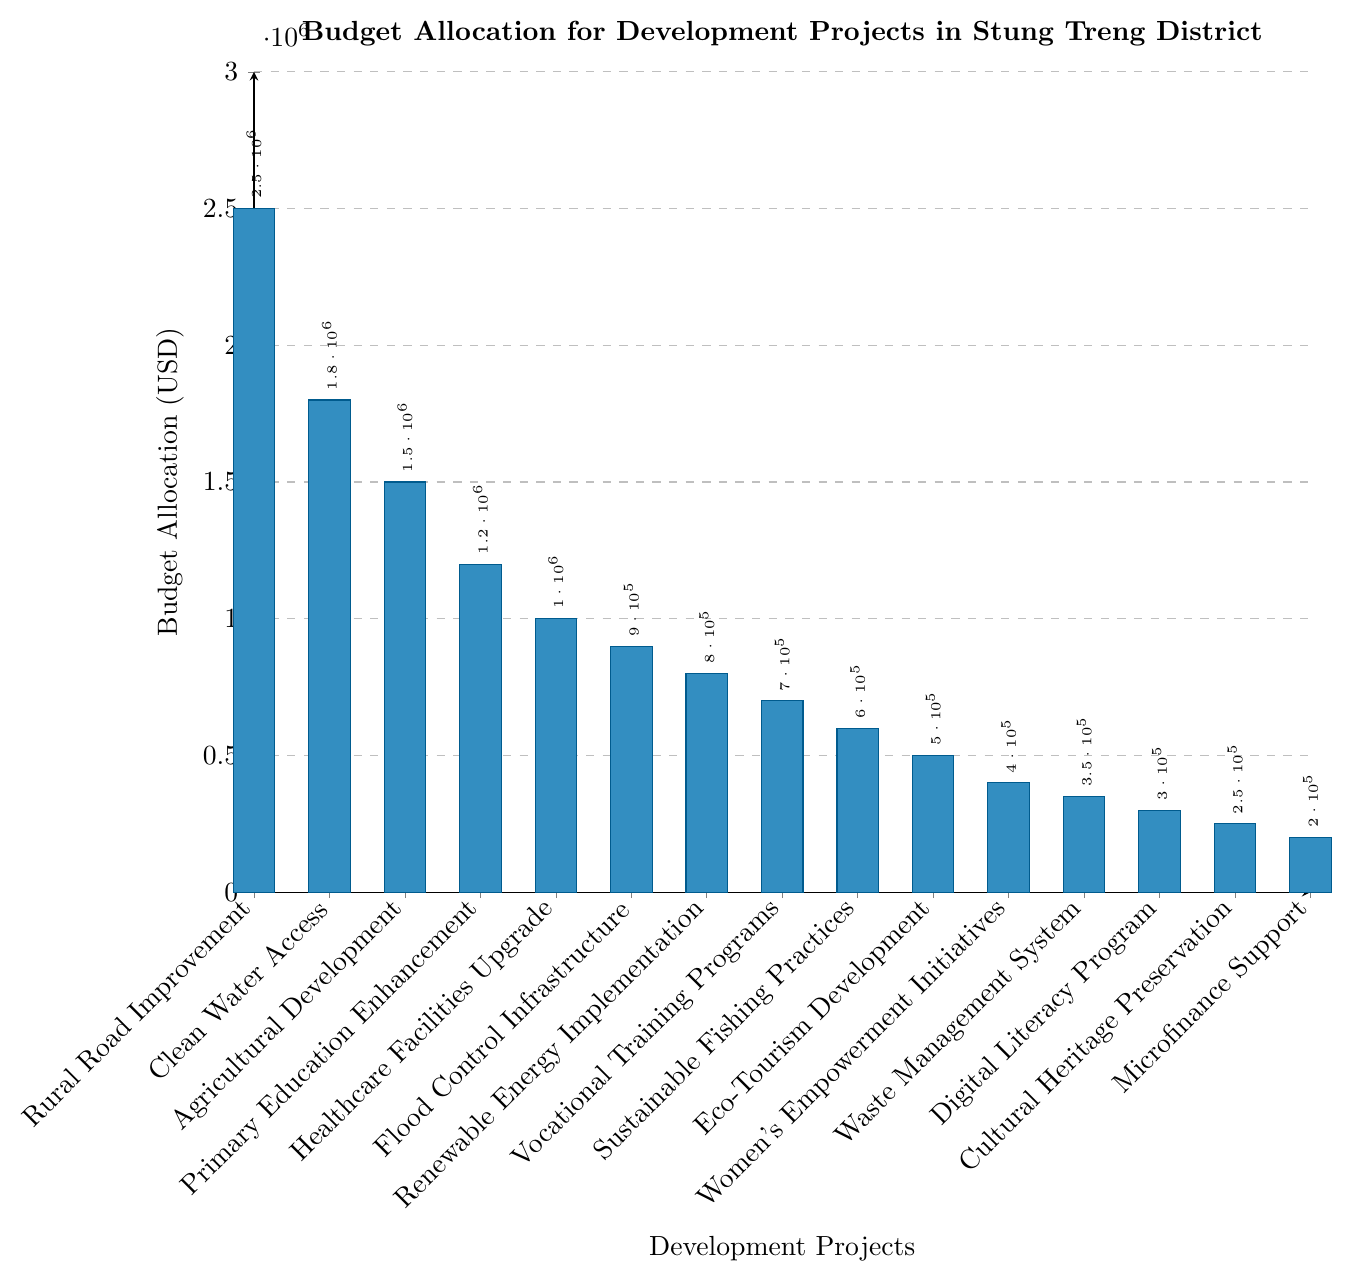Which project has the highest budget allocation? The figure shows a bar chart with each bar representing a project's budget allocation. The bar for "Rural Road Improvement" is the tallest, indicating it has the highest budget allocation.
Answer: Rural Road Improvement Which project has the lowest budget allocation? The chart indicates that the bar for "Microfinance Support" is the shortest among all bars, making it the project with the lowest budget allocation.
Answer: Microfinance Support How much more budget is allocated to Clean Water Access compared to Renewable Energy Implementation? Find the heights of the bars for "Clean Water Access" and "Renewable Energy Implementation". The difference is $1,800,000 - $800,000 = $1,000,000.
Answer: $1,000,000 **Compositional Questions:**
   
What is the total budget allocated to the projects focused on environmental sustainability (Flood Control Infrastructure, Renewable Energy Implementation, Sustainable Fishing Practices)? Sum the budgets for "Flood Control Infrastructure" ($900,000), "Renewable Energy Implementation" ($800,000), and "Sustainable Fishing Practices" ($600,000). The total is $900,000 + $800,000 + $600,000 = $2,300,000.
Answer: $2,300,000 What is the average budget allocation for the top 3 projects? Identify the top three projects: "Rural Road Improvement", "Clean Water Access", and "Agricultural Development" with budgets $2,500,000, $1,800,000, and $1,500,000 respectively. The average is calculated as ($2,500,000 + $1,800,000 + $1,500,000) / 3 = $5,800,000 / 3 ≈ $1,933,333.33
Answer: $1,933,333.33 What is the total budget allocated to Healthcare Facilities Upgrade and Primary Education Enhancement? Add the budget allocations for "Healthcare Facilities Upgrade" ($1,000,000) and "Primary Education Enhancement" ($1,200,000). $1,000,000 + $1,200,000 = $2,200,000
Answer: $2,200,000 Which bar is the second tallest? Observe the heights of all bars in the chart. The second tallest bar corresponds to the "Clean Water Access" project.
Answer: Clean Water Access How many projects have a budget allocation greater than $1,000,000? Count the number of bars that surpass the $1,000,000 mark. The bars for "Rural Road Improvement", "Clean Water Access", "Agricultural Development", and "Primary Education Enhancement" are greater than $1,000,000. There are 4 such projects.
Answer: 4 Which project does the shortest green bar represent? Assuming a specific color scheme (green) used consistently in the figure, identify the project with the shortest green bar which is "Microfinance Support".
Answer: Microfinance Support 